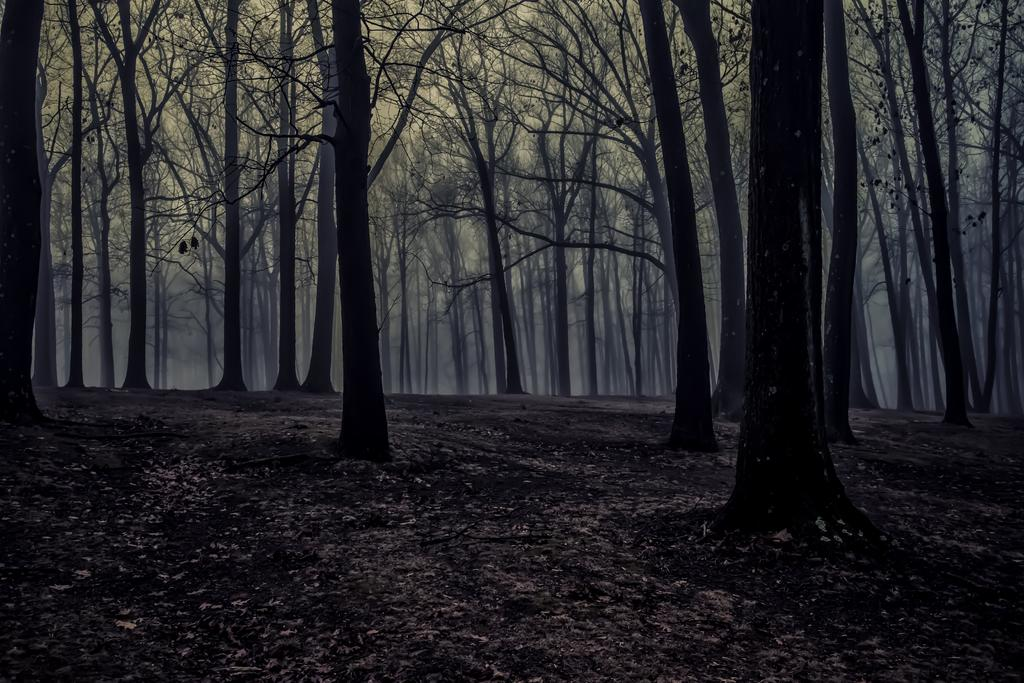What is the main setting of the image? The main setting of the image is an open ground. Are there any natural elements present in the image? Yes, there are multiple trees in the image. Can you see any fairies dancing around the trees in the image? There are no fairies present in the image; it only features an open ground and trees. 